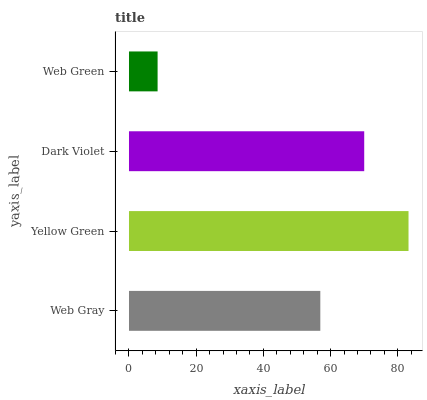Is Web Green the minimum?
Answer yes or no. Yes. Is Yellow Green the maximum?
Answer yes or no. Yes. Is Dark Violet the minimum?
Answer yes or no. No. Is Dark Violet the maximum?
Answer yes or no. No. Is Yellow Green greater than Dark Violet?
Answer yes or no. Yes. Is Dark Violet less than Yellow Green?
Answer yes or no. Yes. Is Dark Violet greater than Yellow Green?
Answer yes or no. No. Is Yellow Green less than Dark Violet?
Answer yes or no. No. Is Dark Violet the high median?
Answer yes or no. Yes. Is Web Gray the low median?
Answer yes or no. Yes. Is Web Gray the high median?
Answer yes or no. No. Is Yellow Green the low median?
Answer yes or no. No. 